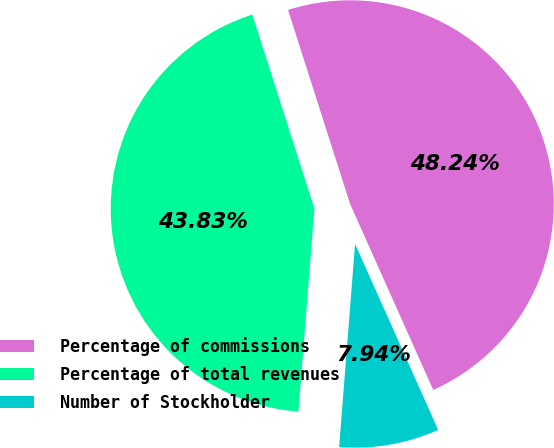Convert chart to OTSL. <chart><loc_0><loc_0><loc_500><loc_500><pie_chart><fcel>Percentage of commissions<fcel>Percentage of total revenues<fcel>Number of Stockholder<nl><fcel>48.24%<fcel>43.83%<fcel>7.94%<nl></chart> 